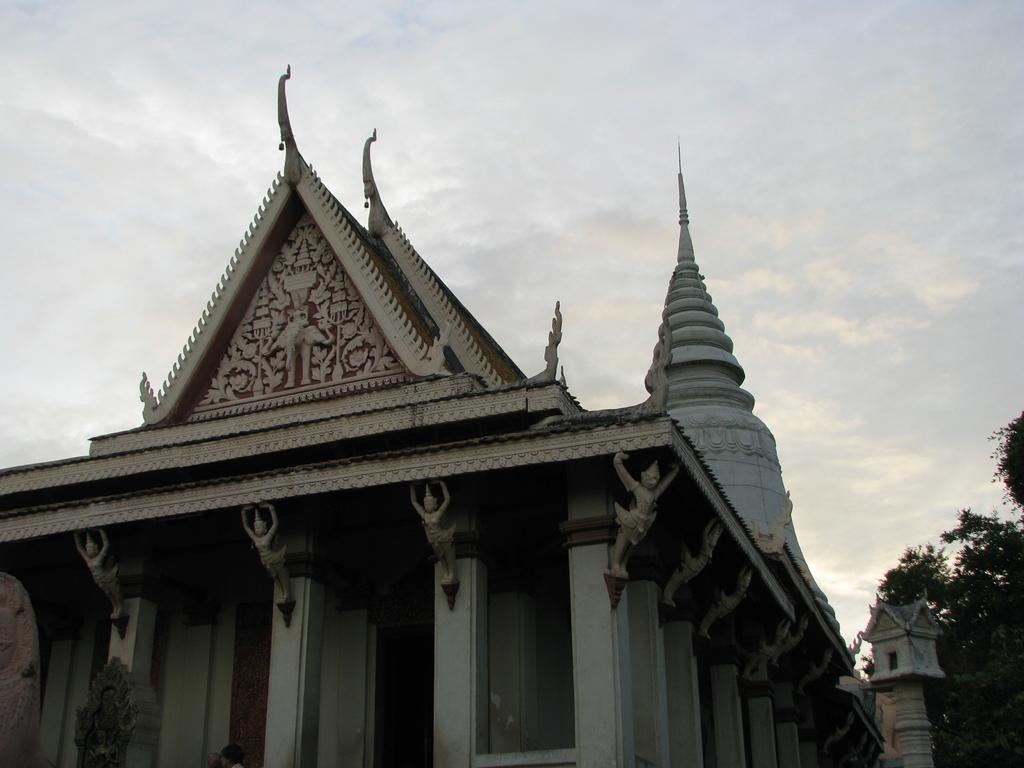Could you give a brief overview of what you see in this image? In this image we can see a building with some sculptures. On the right side of the image there are trees. In the background of the image there is the sky. 